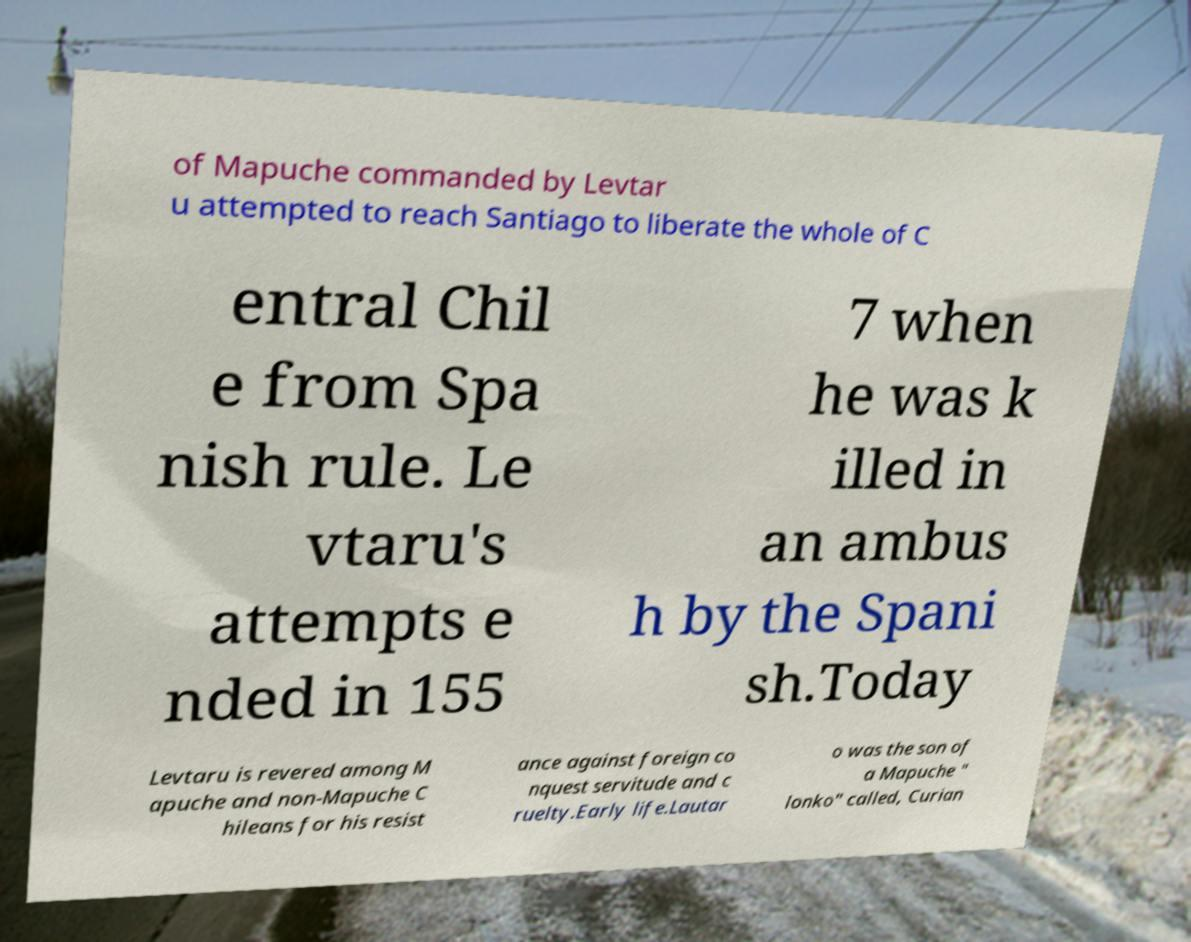Can you accurately transcribe the text from the provided image for me? of Mapuche commanded by Levtar u attempted to reach Santiago to liberate the whole of C entral Chil e from Spa nish rule. Le vtaru's attempts e nded in 155 7 when he was k illed in an ambus h by the Spani sh.Today Levtaru is revered among M apuche and non-Mapuche C hileans for his resist ance against foreign co nquest servitude and c ruelty.Early life.Lautar o was the son of a Mapuche " lonko" called, Curian 